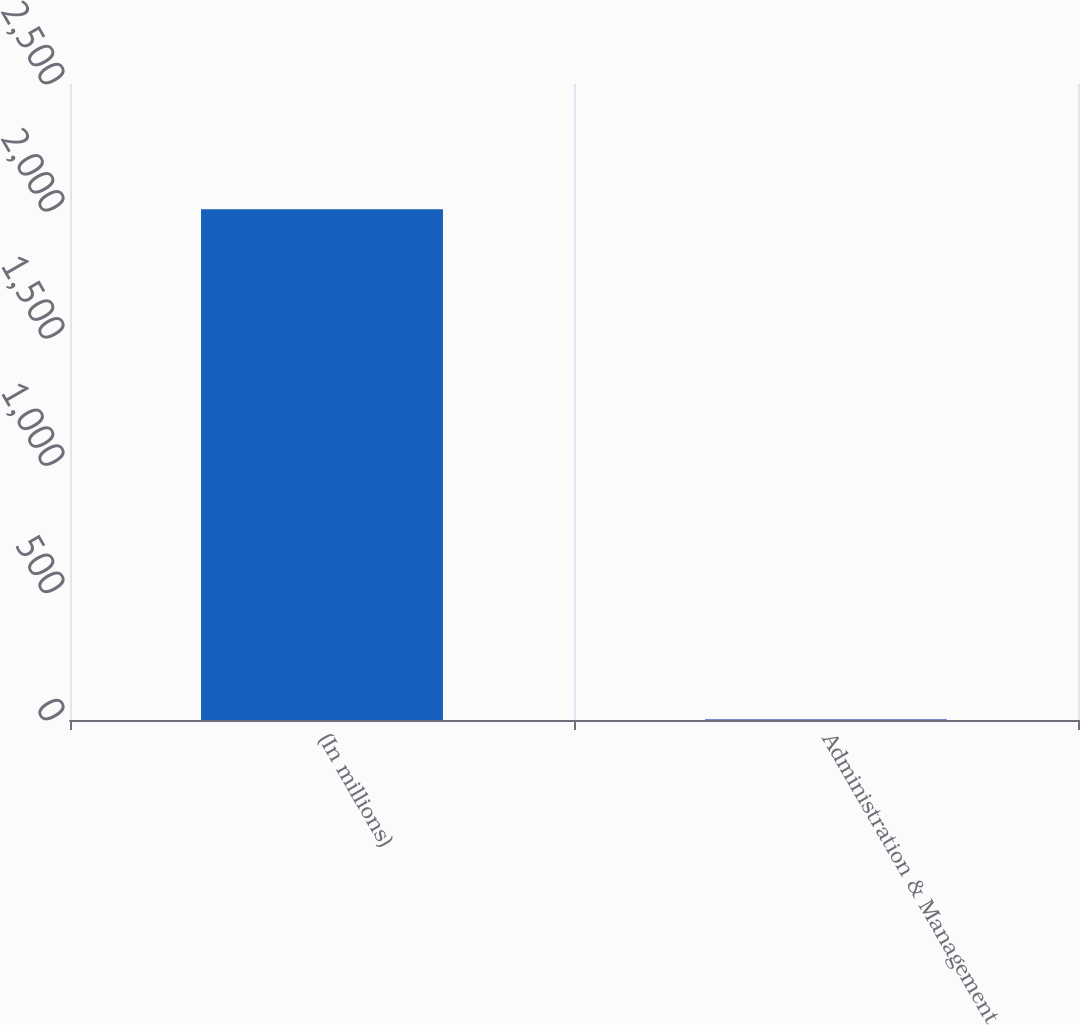<chart> <loc_0><loc_0><loc_500><loc_500><bar_chart><fcel>(In millions)<fcel>Administration & Management<nl><fcel>2008<fcel>1.6<nl></chart> 